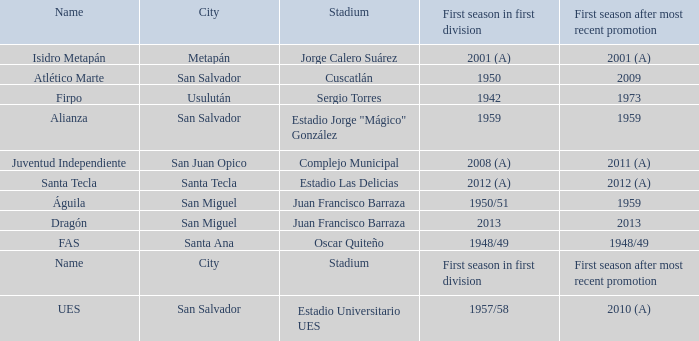When was Alianza's first season in first division with a promotion after 1959? 1959.0. 